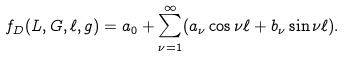Convert formula to latex. <formula><loc_0><loc_0><loc_500><loc_500>f _ { D } ( L , G , \ell , g ) = a _ { 0 } + \sum _ { \nu = 1 } ^ { \infty } ( a _ { \nu } \cos { \nu \ell } + b _ { \nu } \sin { \nu \ell } ) .</formula> 